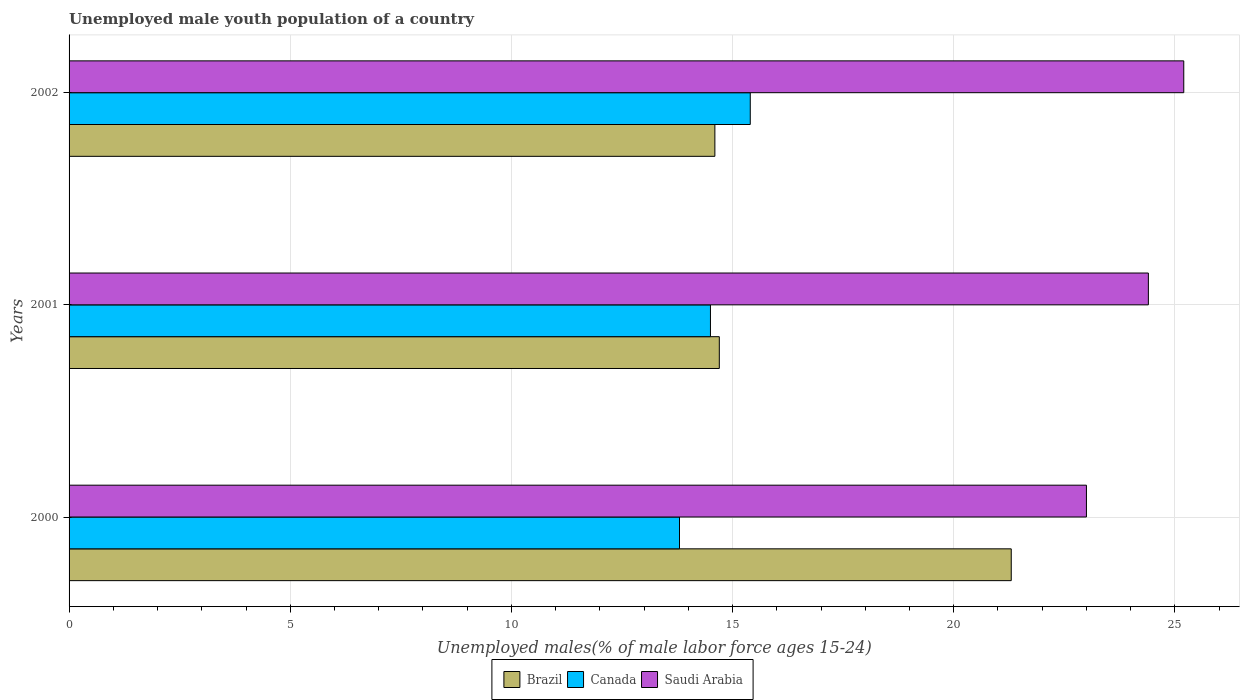How many groups of bars are there?
Your answer should be compact. 3. How many bars are there on the 2nd tick from the top?
Ensure brevity in your answer.  3. How many bars are there on the 3rd tick from the bottom?
Offer a terse response. 3. What is the percentage of unemployed male youth population in Saudi Arabia in 2002?
Provide a succinct answer. 25.2. Across all years, what is the maximum percentage of unemployed male youth population in Saudi Arabia?
Your response must be concise. 25.2. In which year was the percentage of unemployed male youth population in Saudi Arabia maximum?
Ensure brevity in your answer.  2002. What is the total percentage of unemployed male youth population in Canada in the graph?
Offer a very short reply. 43.7. What is the difference between the percentage of unemployed male youth population in Brazil in 2000 and that in 2002?
Offer a very short reply. 6.7. What is the difference between the percentage of unemployed male youth population in Saudi Arabia in 2001 and the percentage of unemployed male youth population in Brazil in 2002?
Provide a short and direct response. 9.8. What is the average percentage of unemployed male youth population in Brazil per year?
Keep it short and to the point. 16.87. In the year 2002, what is the difference between the percentage of unemployed male youth population in Brazil and percentage of unemployed male youth population in Saudi Arabia?
Ensure brevity in your answer.  -10.6. What is the ratio of the percentage of unemployed male youth population in Saudi Arabia in 2000 to that in 2001?
Give a very brief answer. 0.94. What is the difference between the highest and the second highest percentage of unemployed male youth population in Saudi Arabia?
Offer a terse response. 0.8. What is the difference between the highest and the lowest percentage of unemployed male youth population in Brazil?
Your answer should be very brief. 6.7. In how many years, is the percentage of unemployed male youth population in Brazil greater than the average percentage of unemployed male youth population in Brazil taken over all years?
Offer a terse response. 1. What does the 2nd bar from the top in 2001 represents?
Offer a terse response. Canada. What does the 3rd bar from the bottom in 2002 represents?
Give a very brief answer. Saudi Arabia. How many bars are there?
Make the answer very short. 9. Are all the bars in the graph horizontal?
Make the answer very short. Yes. How many years are there in the graph?
Offer a terse response. 3. Are the values on the major ticks of X-axis written in scientific E-notation?
Keep it short and to the point. No. Does the graph contain any zero values?
Give a very brief answer. No. How many legend labels are there?
Give a very brief answer. 3. How are the legend labels stacked?
Make the answer very short. Horizontal. What is the title of the graph?
Your answer should be very brief. Unemployed male youth population of a country. Does "Guinea" appear as one of the legend labels in the graph?
Ensure brevity in your answer.  No. What is the label or title of the X-axis?
Your answer should be very brief. Unemployed males(% of male labor force ages 15-24). What is the Unemployed males(% of male labor force ages 15-24) of Brazil in 2000?
Give a very brief answer. 21.3. What is the Unemployed males(% of male labor force ages 15-24) in Canada in 2000?
Make the answer very short. 13.8. What is the Unemployed males(% of male labor force ages 15-24) in Brazil in 2001?
Your answer should be compact. 14.7. What is the Unemployed males(% of male labor force ages 15-24) in Canada in 2001?
Give a very brief answer. 14.5. What is the Unemployed males(% of male labor force ages 15-24) in Saudi Arabia in 2001?
Give a very brief answer. 24.4. What is the Unemployed males(% of male labor force ages 15-24) of Brazil in 2002?
Ensure brevity in your answer.  14.6. What is the Unemployed males(% of male labor force ages 15-24) in Canada in 2002?
Your answer should be very brief. 15.4. What is the Unemployed males(% of male labor force ages 15-24) of Saudi Arabia in 2002?
Offer a very short reply. 25.2. Across all years, what is the maximum Unemployed males(% of male labor force ages 15-24) of Brazil?
Provide a short and direct response. 21.3. Across all years, what is the maximum Unemployed males(% of male labor force ages 15-24) of Canada?
Ensure brevity in your answer.  15.4. Across all years, what is the maximum Unemployed males(% of male labor force ages 15-24) in Saudi Arabia?
Offer a terse response. 25.2. Across all years, what is the minimum Unemployed males(% of male labor force ages 15-24) in Brazil?
Provide a succinct answer. 14.6. Across all years, what is the minimum Unemployed males(% of male labor force ages 15-24) of Canada?
Make the answer very short. 13.8. Across all years, what is the minimum Unemployed males(% of male labor force ages 15-24) in Saudi Arabia?
Give a very brief answer. 23. What is the total Unemployed males(% of male labor force ages 15-24) in Brazil in the graph?
Give a very brief answer. 50.6. What is the total Unemployed males(% of male labor force ages 15-24) in Canada in the graph?
Make the answer very short. 43.7. What is the total Unemployed males(% of male labor force ages 15-24) of Saudi Arabia in the graph?
Provide a short and direct response. 72.6. What is the difference between the Unemployed males(% of male labor force ages 15-24) of Canada in 2000 and that in 2001?
Ensure brevity in your answer.  -0.7. What is the difference between the Unemployed males(% of male labor force ages 15-24) of Saudi Arabia in 2000 and that in 2001?
Offer a very short reply. -1.4. What is the difference between the Unemployed males(% of male labor force ages 15-24) in Brazil in 2000 and that in 2002?
Offer a terse response. 6.7. What is the difference between the Unemployed males(% of male labor force ages 15-24) in Canada in 2000 and that in 2002?
Provide a short and direct response. -1.6. What is the difference between the Unemployed males(% of male labor force ages 15-24) of Brazil in 2001 and that in 2002?
Give a very brief answer. 0.1. What is the difference between the Unemployed males(% of male labor force ages 15-24) of Canada in 2001 and that in 2002?
Provide a succinct answer. -0.9. What is the difference between the Unemployed males(% of male labor force ages 15-24) in Saudi Arabia in 2001 and that in 2002?
Make the answer very short. -0.8. What is the difference between the Unemployed males(% of male labor force ages 15-24) of Brazil in 2000 and the Unemployed males(% of male labor force ages 15-24) of Canada in 2001?
Your answer should be compact. 6.8. What is the difference between the Unemployed males(% of male labor force ages 15-24) in Brazil in 2000 and the Unemployed males(% of male labor force ages 15-24) in Saudi Arabia in 2002?
Give a very brief answer. -3.9. What is the difference between the Unemployed males(% of male labor force ages 15-24) of Canada in 2000 and the Unemployed males(% of male labor force ages 15-24) of Saudi Arabia in 2002?
Offer a terse response. -11.4. What is the average Unemployed males(% of male labor force ages 15-24) of Brazil per year?
Offer a terse response. 16.87. What is the average Unemployed males(% of male labor force ages 15-24) in Canada per year?
Provide a succinct answer. 14.57. What is the average Unemployed males(% of male labor force ages 15-24) in Saudi Arabia per year?
Give a very brief answer. 24.2. In the year 2001, what is the difference between the Unemployed males(% of male labor force ages 15-24) of Brazil and Unemployed males(% of male labor force ages 15-24) of Saudi Arabia?
Your response must be concise. -9.7. In the year 2002, what is the difference between the Unemployed males(% of male labor force ages 15-24) in Brazil and Unemployed males(% of male labor force ages 15-24) in Canada?
Your response must be concise. -0.8. What is the ratio of the Unemployed males(% of male labor force ages 15-24) of Brazil in 2000 to that in 2001?
Make the answer very short. 1.45. What is the ratio of the Unemployed males(% of male labor force ages 15-24) in Canada in 2000 to that in 2001?
Provide a succinct answer. 0.95. What is the ratio of the Unemployed males(% of male labor force ages 15-24) of Saudi Arabia in 2000 to that in 2001?
Provide a short and direct response. 0.94. What is the ratio of the Unemployed males(% of male labor force ages 15-24) of Brazil in 2000 to that in 2002?
Provide a short and direct response. 1.46. What is the ratio of the Unemployed males(% of male labor force ages 15-24) in Canada in 2000 to that in 2002?
Your answer should be very brief. 0.9. What is the ratio of the Unemployed males(% of male labor force ages 15-24) of Saudi Arabia in 2000 to that in 2002?
Make the answer very short. 0.91. What is the ratio of the Unemployed males(% of male labor force ages 15-24) in Brazil in 2001 to that in 2002?
Your answer should be very brief. 1.01. What is the ratio of the Unemployed males(% of male labor force ages 15-24) in Canada in 2001 to that in 2002?
Your answer should be compact. 0.94. What is the ratio of the Unemployed males(% of male labor force ages 15-24) of Saudi Arabia in 2001 to that in 2002?
Give a very brief answer. 0.97. What is the difference between the highest and the second highest Unemployed males(% of male labor force ages 15-24) of Saudi Arabia?
Your answer should be very brief. 0.8. What is the difference between the highest and the lowest Unemployed males(% of male labor force ages 15-24) in Brazil?
Provide a succinct answer. 6.7. What is the difference between the highest and the lowest Unemployed males(% of male labor force ages 15-24) of Canada?
Your answer should be compact. 1.6. 